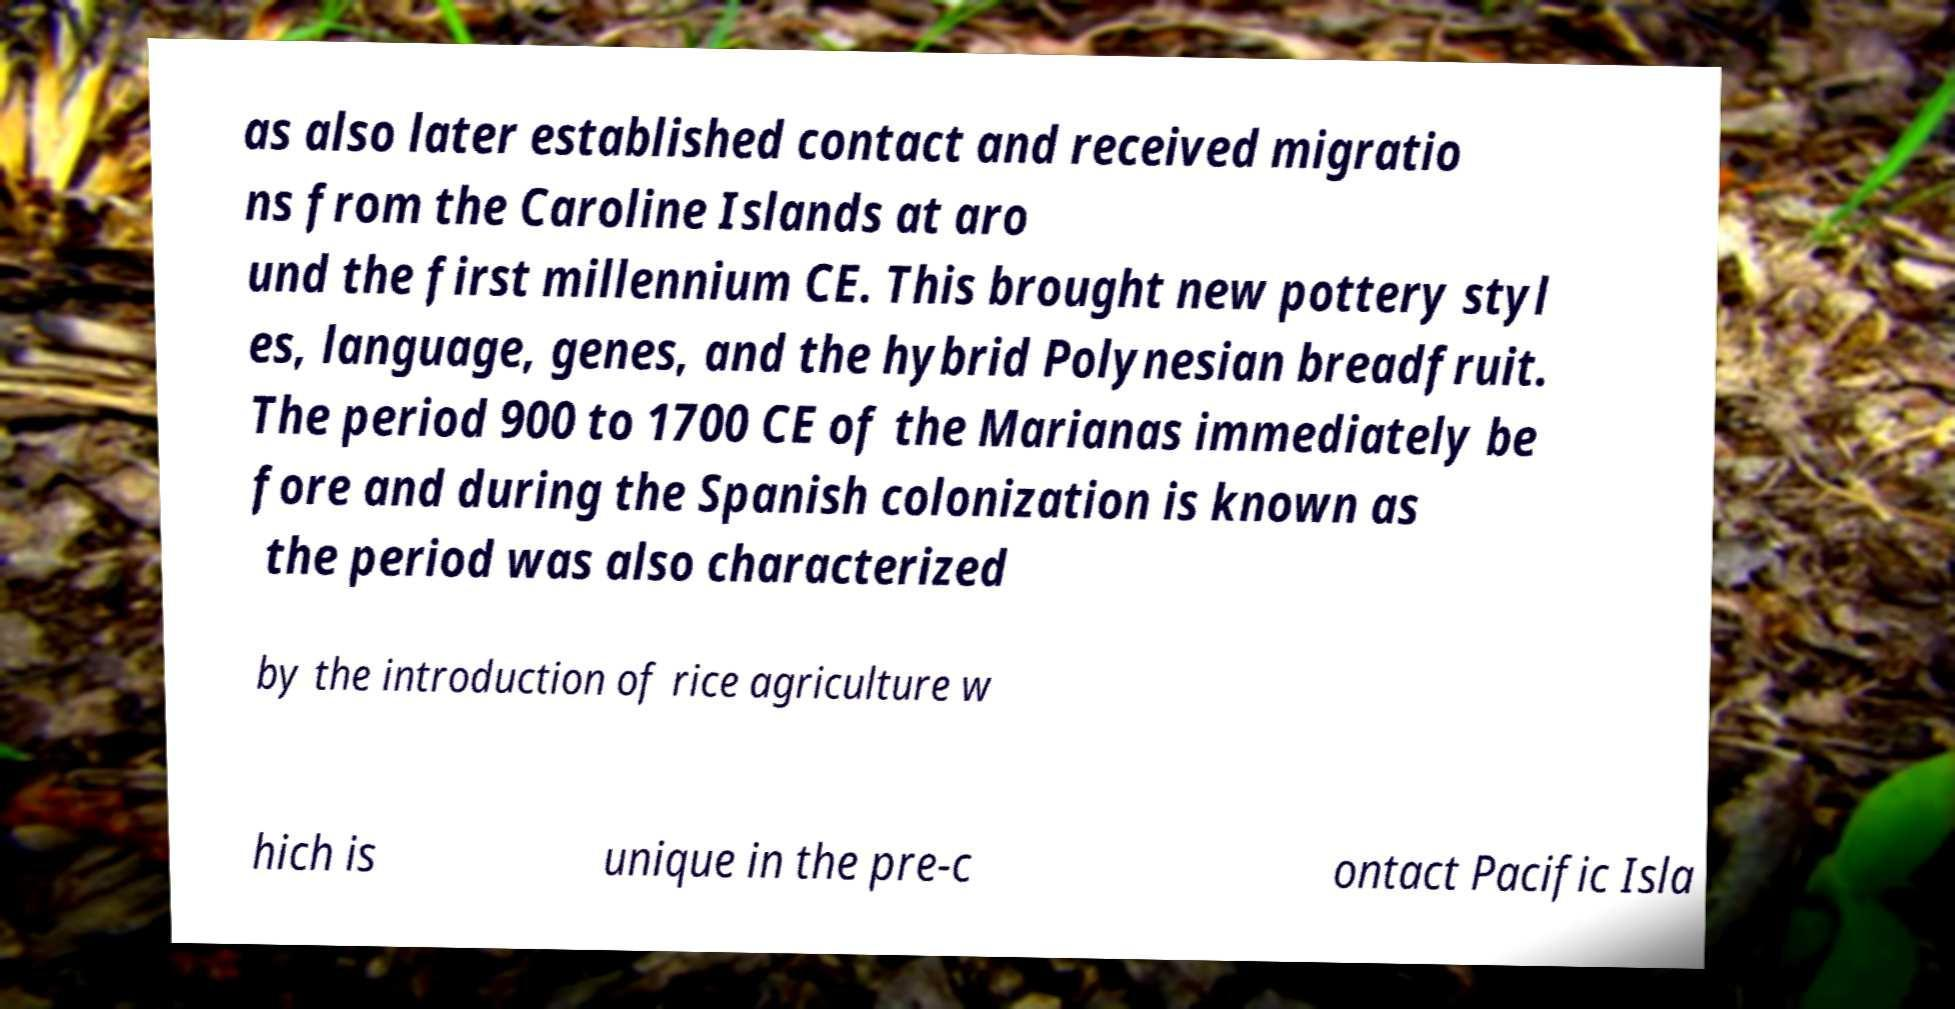Please identify and transcribe the text found in this image. as also later established contact and received migratio ns from the Caroline Islands at aro und the first millennium CE. This brought new pottery styl es, language, genes, and the hybrid Polynesian breadfruit. The period 900 to 1700 CE of the Marianas immediately be fore and during the Spanish colonization is known as the period was also characterized by the introduction of rice agriculture w hich is unique in the pre-c ontact Pacific Isla 